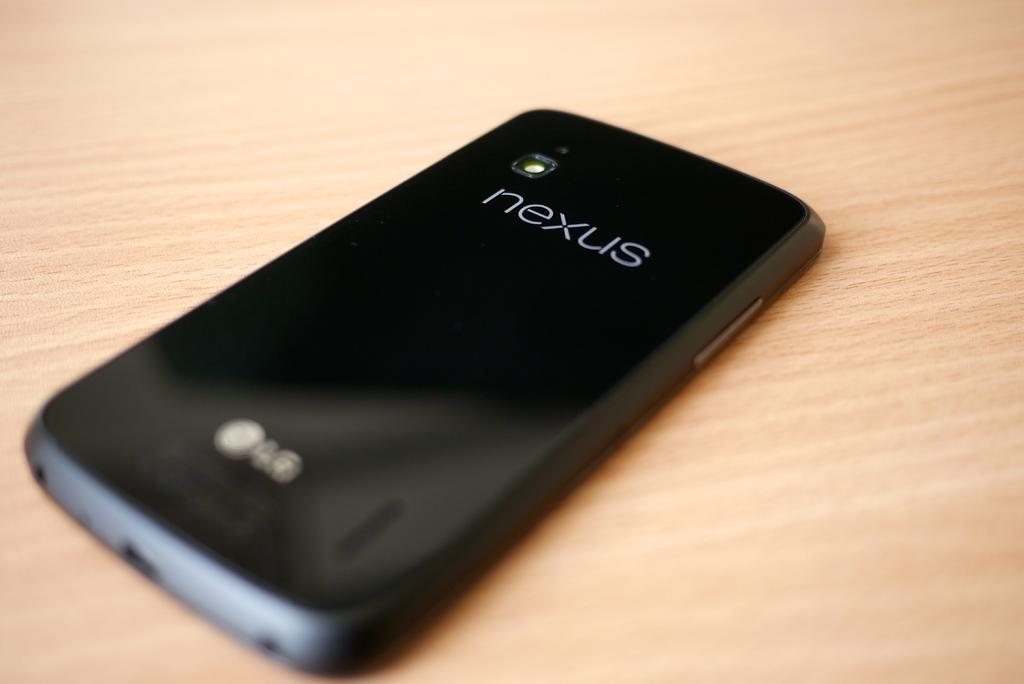<image>
Provide a brief description of the given image. A black smartphone from LG is on a wooden surface. 